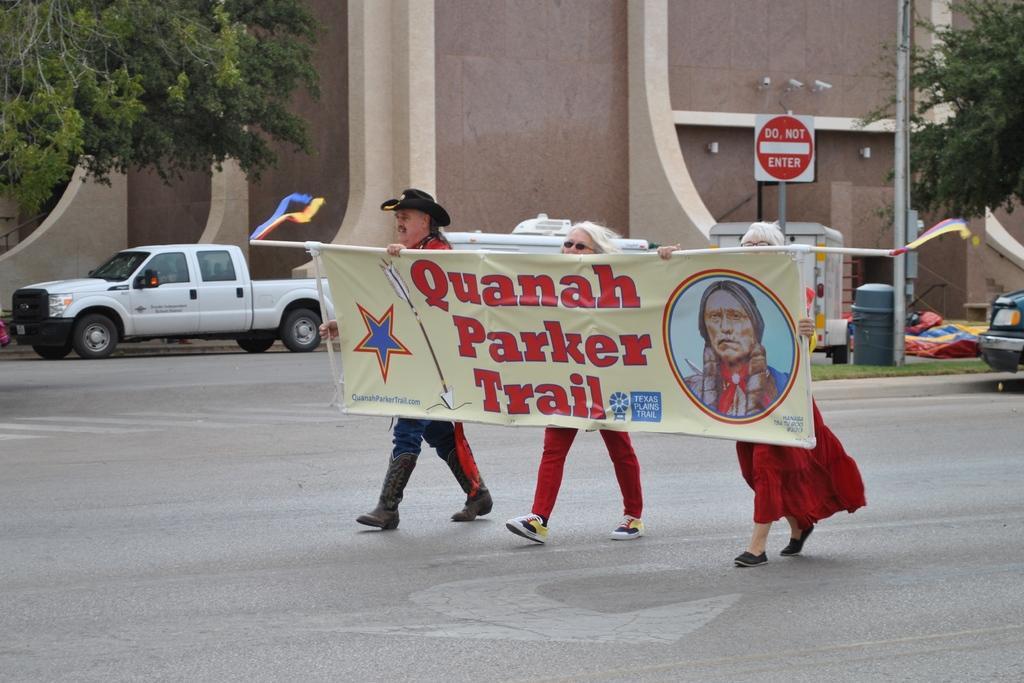In one or two sentences, can you explain what this image depicts? In this image we can see three persons standing on the ground holding a banner with text. On the left side of the image we can see car placed on the ground. In the background, we can see a building, group of trees, a sign board and two vehicles. 